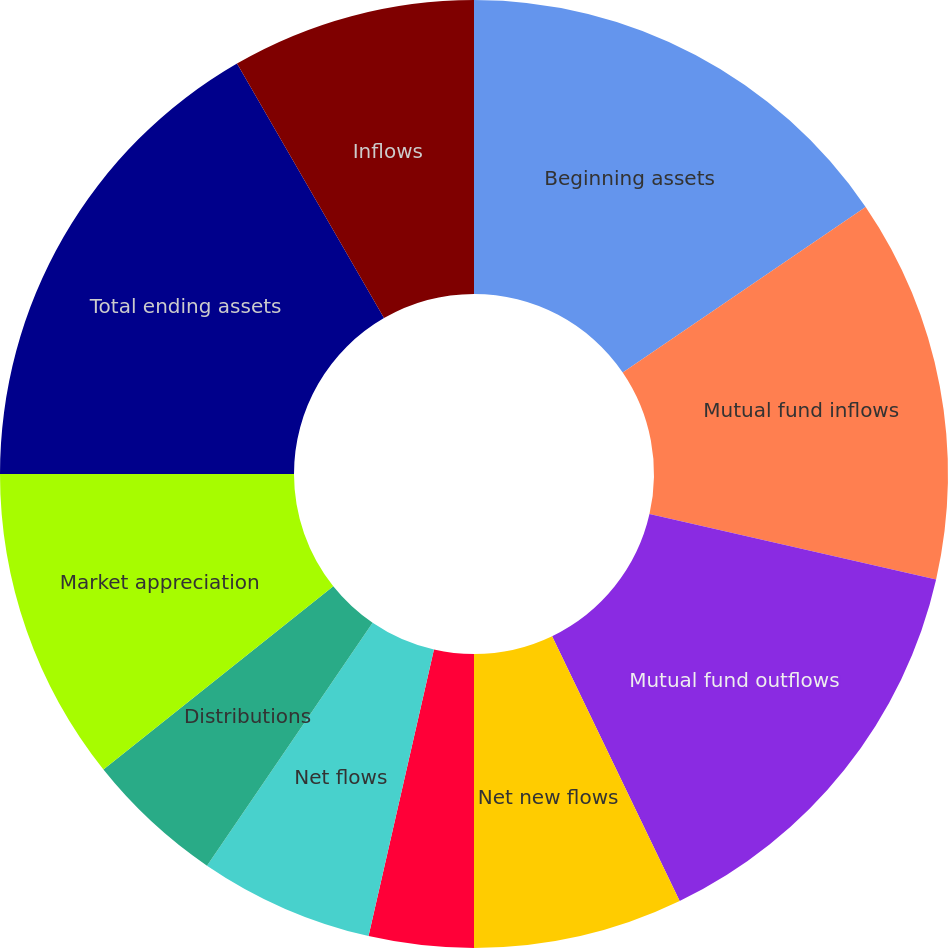Convert chart. <chart><loc_0><loc_0><loc_500><loc_500><pie_chart><fcel>Beginning assets<fcel>Mutual fund inflows<fcel>Mutual fund outflows<fcel>Net new flows<fcel>Reinvested dividends<fcel>Net flows<fcel>Distributions<fcel>Market appreciation<fcel>Total ending assets<fcel>Inflows<nl><fcel>15.47%<fcel>13.09%<fcel>14.28%<fcel>7.14%<fcel>3.57%<fcel>5.95%<fcel>4.76%<fcel>10.71%<fcel>16.66%<fcel>8.33%<nl></chart> 